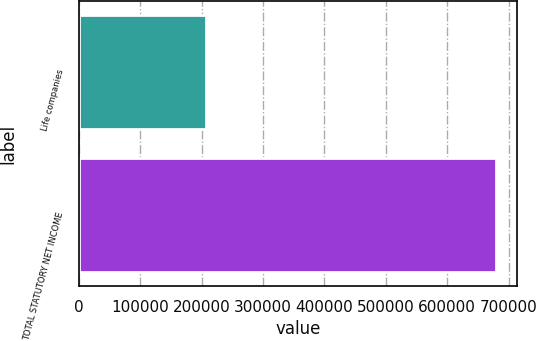Convert chart. <chart><loc_0><loc_0><loc_500><loc_500><bar_chart><fcel>Life companies<fcel>TOTAL STATUTORY NET INCOME<nl><fcel>206817<fcel>680008<nl></chart> 